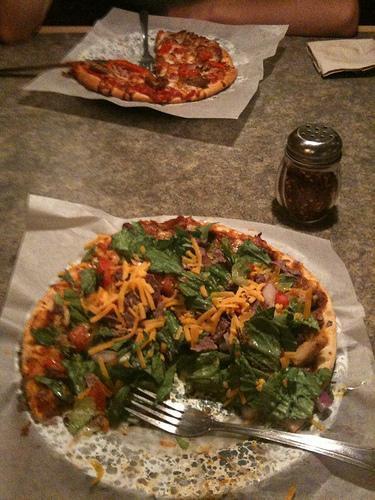How many pizzas can be seen?
Give a very brief answer. 2. 